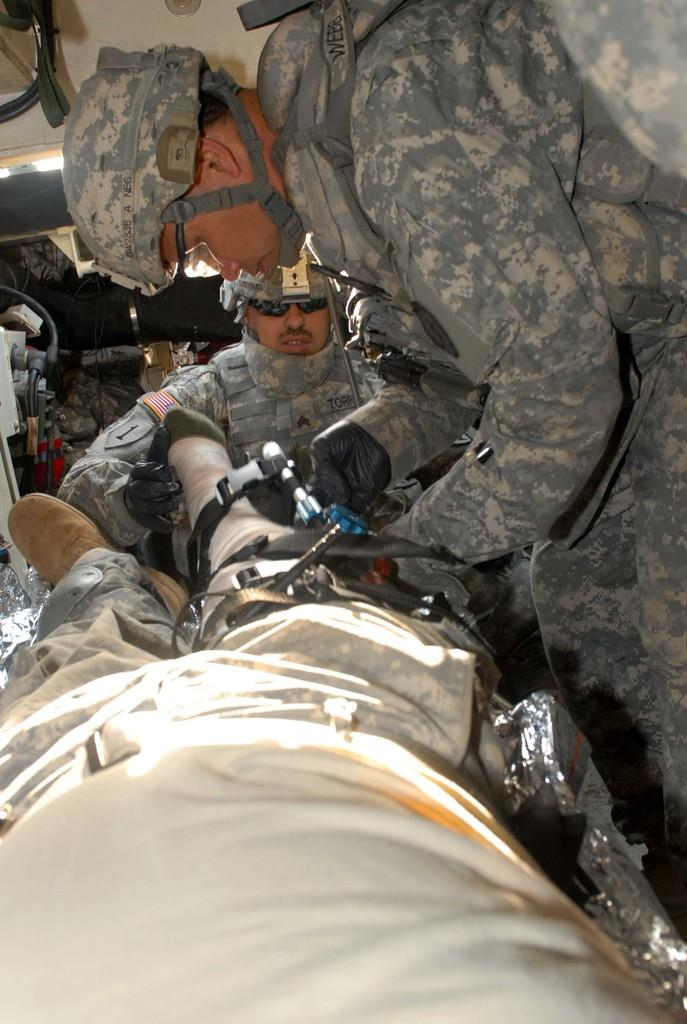How many people are present in the image? There are two people in the image. What are the two people doing in the image? The two people are operating a person. What can be seen in the background of the image? There are objects in the background of the image. Can you describe the lighting in the image? There are lights on top of the image. How many fingers does the uncle have in the image? There is no uncle present in the image, so it is not possible to determine the number of fingers he might have. 